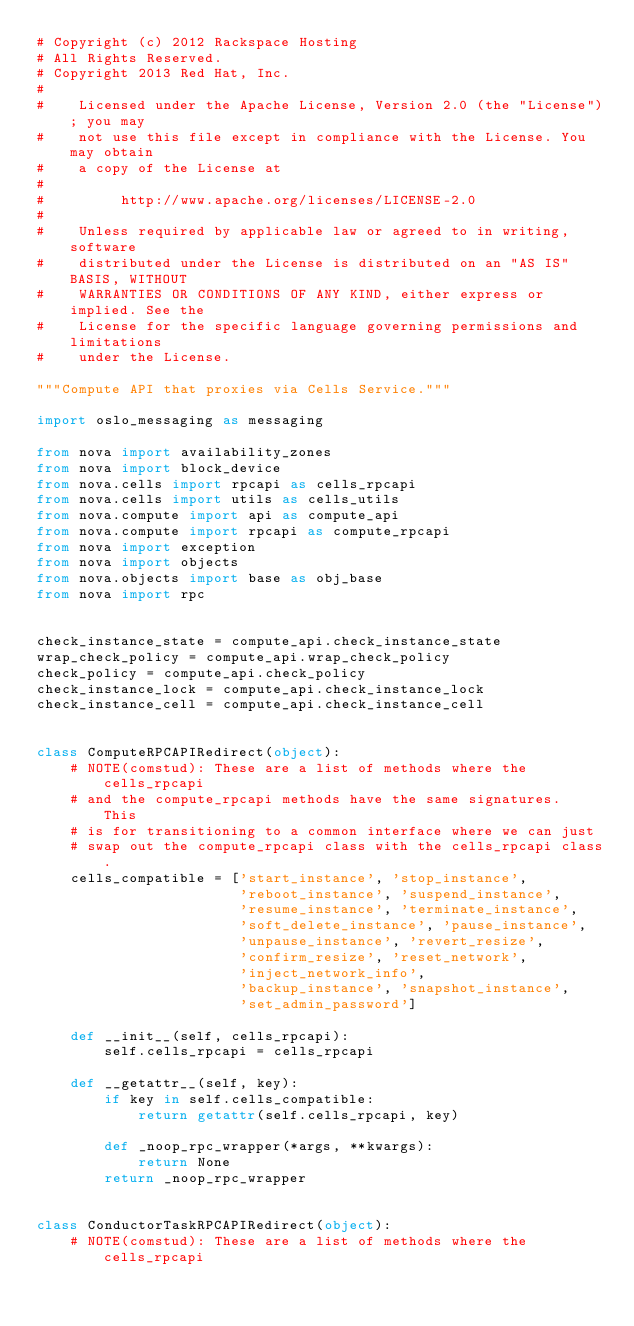<code> <loc_0><loc_0><loc_500><loc_500><_Python_># Copyright (c) 2012 Rackspace Hosting
# All Rights Reserved.
# Copyright 2013 Red Hat, Inc.
#
#    Licensed under the Apache License, Version 2.0 (the "License"); you may
#    not use this file except in compliance with the License. You may obtain
#    a copy of the License at
#
#         http://www.apache.org/licenses/LICENSE-2.0
#
#    Unless required by applicable law or agreed to in writing, software
#    distributed under the License is distributed on an "AS IS" BASIS, WITHOUT
#    WARRANTIES OR CONDITIONS OF ANY KIND, either express or implied. See the
#    License for the specific language governing permissions and limitations
#    under the License.

"""Compute API that proxies via Cells Service."""

import oslo_messaging as messaging

from nova import availability_zones
from nova import block_device
from nova.cells import rpcapi as cells_rpcapi
from nova.cells import utils as cells_utils
from nova.compute import api as compute_api
from nova.compute import rpcapi as compute_rpcapi
from nova import exception
from nova import objects
from nova.objects import base as obj_base
from nova import rpc


check_instance_state = compute_api.check_instance_state
wrap_check_policy = compute_api.wrap_check_policy
check_policy = compute_api.check_policy
check_instance_lock = compute_api.check_instance_lock
check_instance_cell = compute_api.check_instance_cell


class ComputeRPCAPIRedirect(object):
    # NOTE(comstud): These are a list of methods where the cells_rpcapi
    # and the compute_rpcapi methods have the same signatures.  This
    # is for transitioning to a common interface where we can just
    # swap out the compute_rpcapi class with the cells_rpcapi class.
    cells_compatible = ['start_instance', 'stop_instance',
                        'reboot_instance', 'suspend_instance',
                        'resume_instance', 'terminate_instance',
                        'soft_delete_instance', 'pause_instance',
                        'unpause_instance', 'revert_resize',
                        'confirm_resize', 'reset_network',
                        'inject_network_info',
                        'backup_instance', 'snapshot_instance',
                        'set_admin_password']

    def __init__(self, cells_rpcapi):
        self.cells_rpcapi = cells_rpcapi

    def __getattr__(self, key):
        if key in self.cells_compatible:
            return getattr(self.cells_rpcapi, key)

        def _noop_rpc_wrapper(*args, **kwargs):
            return None
        return _noop_rpc_wrapper


class ConductorTaskRPCAPIRedirect(object):
    # NOTE(comstud): These are a list of methods where the cells_rpcapi</code> 